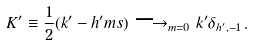Convert formula to latex. <formula><loc_0><loc_0><loc_500><loc_500>K ^ { \prime } \equiv \frac { 1 } { 2 } ( k ^ { \prime } - h ^ { \prime } m s ) \longrightarrow _ { m = 0 } k ^ { \prime } \delta _ { h ^ { \prime } , - 1 } \, .</formula> 